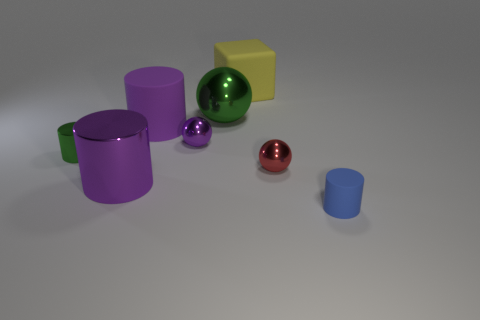Is there a large sphere that has the same material as the tiny blue cylinder?
Keep it short and to the point. No. What is the shape of the tiny green metal thing?
Your response must be concise. Cylinder. There is a tiny cylinder that is made of the same material as the cube; what color is it?
Keep it short and to the point. Blue. How many brown things are either big matte cylinders or spheres?
Your response must be concise. 0. Is the number of tiny blue matte balls greater than the number of large purple cylinders?
Offer a terse response. No. What number of objects are either rubber objects that are behind the blue rubber cylinder or things on the left side of the cube?
Keep it short and to the point. 6. The sphere that is the same size as the purple rubber thing is what color?
Offer a very short reply. Green. Do the big green thing and the large yellow object have the same material?
Make the answer very short. No. What is the material of the large object in front of the tiny red metal thing to the right of the small purple shiny sphere?
Offer a very short reply. Metal. Is the number of shiny objects behind the purple shiny sphere greater than the number of cyan matte cylinders?
Your response must be concise. Yes. 